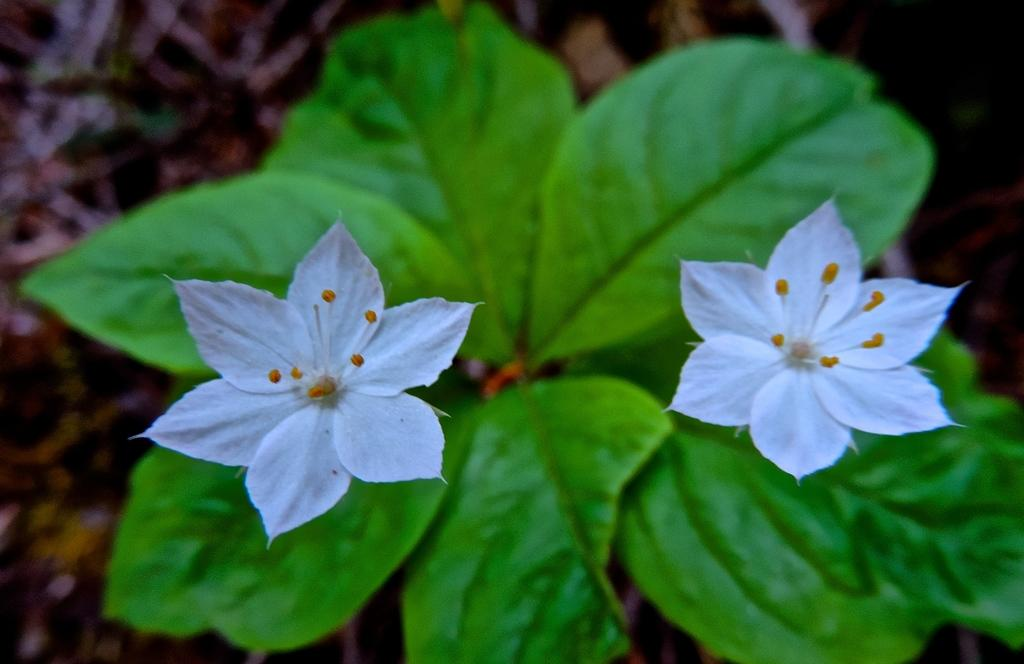What type of plants can be seen in the image? There are flowers and leaves in the image. Can you describe the appearance of the flowers? Unfortunately, the specific appearance of the flowers cannot be determined from the provided facts. Are there any other elements present in the image besides the flowers and leaves? No additional elements are mentioned in the provided facts. What type of quilt is being used as a stage for the rail in the image? There is no quilt, rail, or stage present in the image; it only features flowers and leaves. 